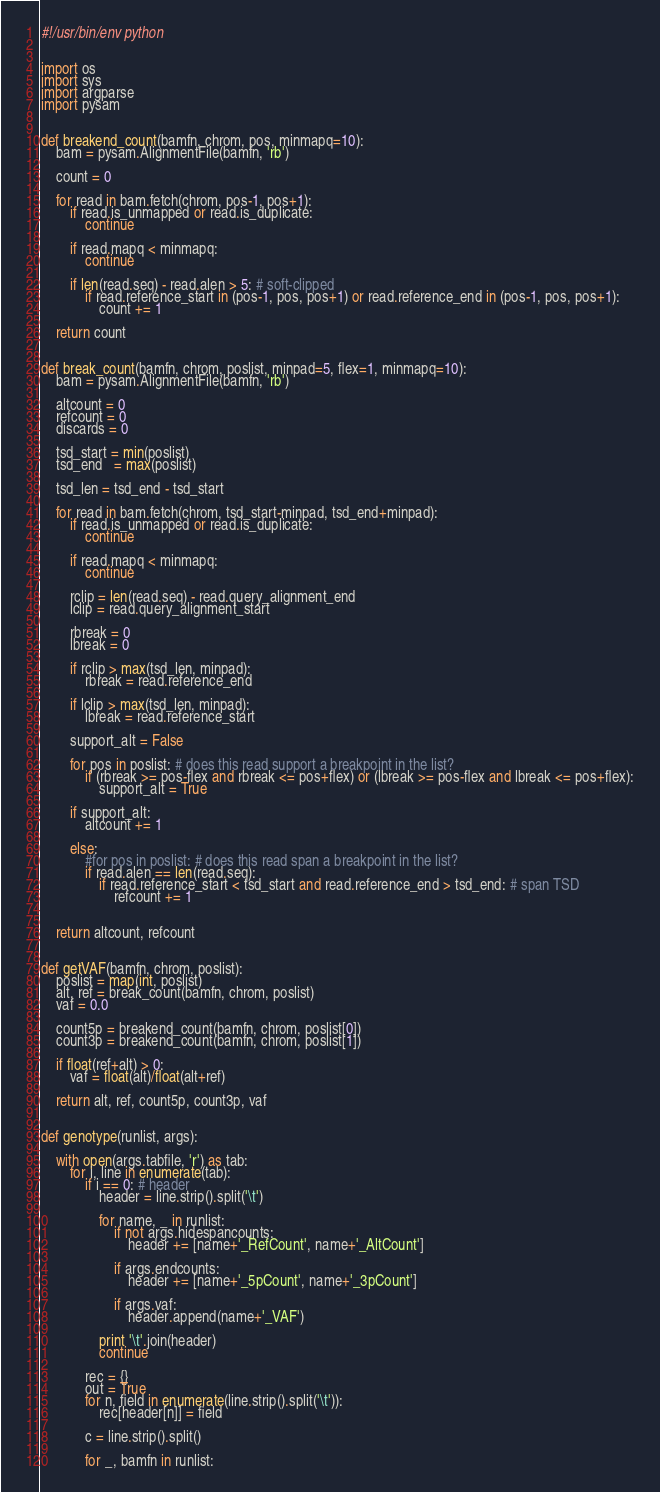<code> <loc_0><loc_0><loc_500><loc_500><_Python_>#!/usr/bin/env python


import os
import sys
import argparse
import pysam


def breakend_count(bamfn, chrom, pos, minmapq=10):
    bam = pysam.AlignmentFile(bamfn, 'rb')

    count = 0

    for read in bam.fetch(chrom, pos-1, pos+1):
        if read.is_unmapped or read.is_duplicate:
            continue

        if read.mapq < minmapq:
            continue

        if len(read.seq) - read.alen > 5: # soft-clipped
            if read.reference_start in (pos-1, pos, pos+1) or read.reference_end in (pos-1, pos, pos+1):
                count += 1

    return count


def break_count(bamfn, chrom, poslist, minpad=5, flex=1, minmapq=10):
    bam = pysam.AlignmentFile(bamfn, 'rb')

    altcount = 0
    refcount = 0
    discards = 0

    tsd_start = min(poslist)
    tsd_end   = max(poslist)

    tsd_len = tsd_end - tsd_start

    for read in bam.fetch(chrom, tsd_start-minpad, tsd_end+minpad):
        if read.is_unmapped or read.is_duplicate:
            continue

        if read.mapq < minmapq:
            continue

        rclip = len(read.seq) - read.query_alignment_end 
        lclip = read.query_alignment_start

        rbreak = 0
        lbreak = 0

        if rclip > max(tsd_len, minpad):
            rbreak = read.reference_end

        if lclip > max(tsd_len, minpad):
            lbreak = read.reference_start

        support_alt = False

        for pos in poslist: # does this read support a breakpoint in the list?
            if (rbreak >= pos-flex and rbreak <= pos+flex) or (lbreak >= pos-flex and lbreak <= pos+flex):
                support_alt = True

        if support_alt:
            altcount += 1

        else:
            #for pos in poslist: # does this read span a breakpoint in the list?
            if read.alen == len(read.seq):
                if read.reference_start < tsd_start and read.reference_end > tsd_end: # span TSD
                    refcount += 1


    return altcount, refcount


def getVAF(bamfn, chrom, poslist):
    poslist = map(int, poslist)
    alt, ref = break_count(bamfn, chrom, poslist)
    vaf = 0.0 

    count5p = breakend_count(bamfn, chrom, poslist[0]) 
    count3p = breakend_count(bamfn, chrom, poslist[1])

    if float(ref+alt) > 0:
        vaf = float(alt)/float(alt+ref)

    return alt, ref, count5p, count3p, vaf


def genotype(runlist, args):

    with open(args.tabfile, 'r') as tab:
        for i, line in enumerate(tab):
            if i == 0: # header
                header = line.strip().split('\t')

                for name, _ in runlist:
                    if not args.hidespancounts:
                        header += [name+'_RefCount', name+'_AltCount']

                    if args.endcounts:
                        header += [name+'_5pCount', name+'_3pCount']

                    if args.vaf:
                        header.append(name+'_VAF')

                print '\t'.join(header)
                continue

            rec = {}
            out = True
            for n, field in enumerate(line.strip().split('\t')):
                rec[header[n]] = field

            c = line.strip().split()

            for _, bamfn in runlist:</code> 